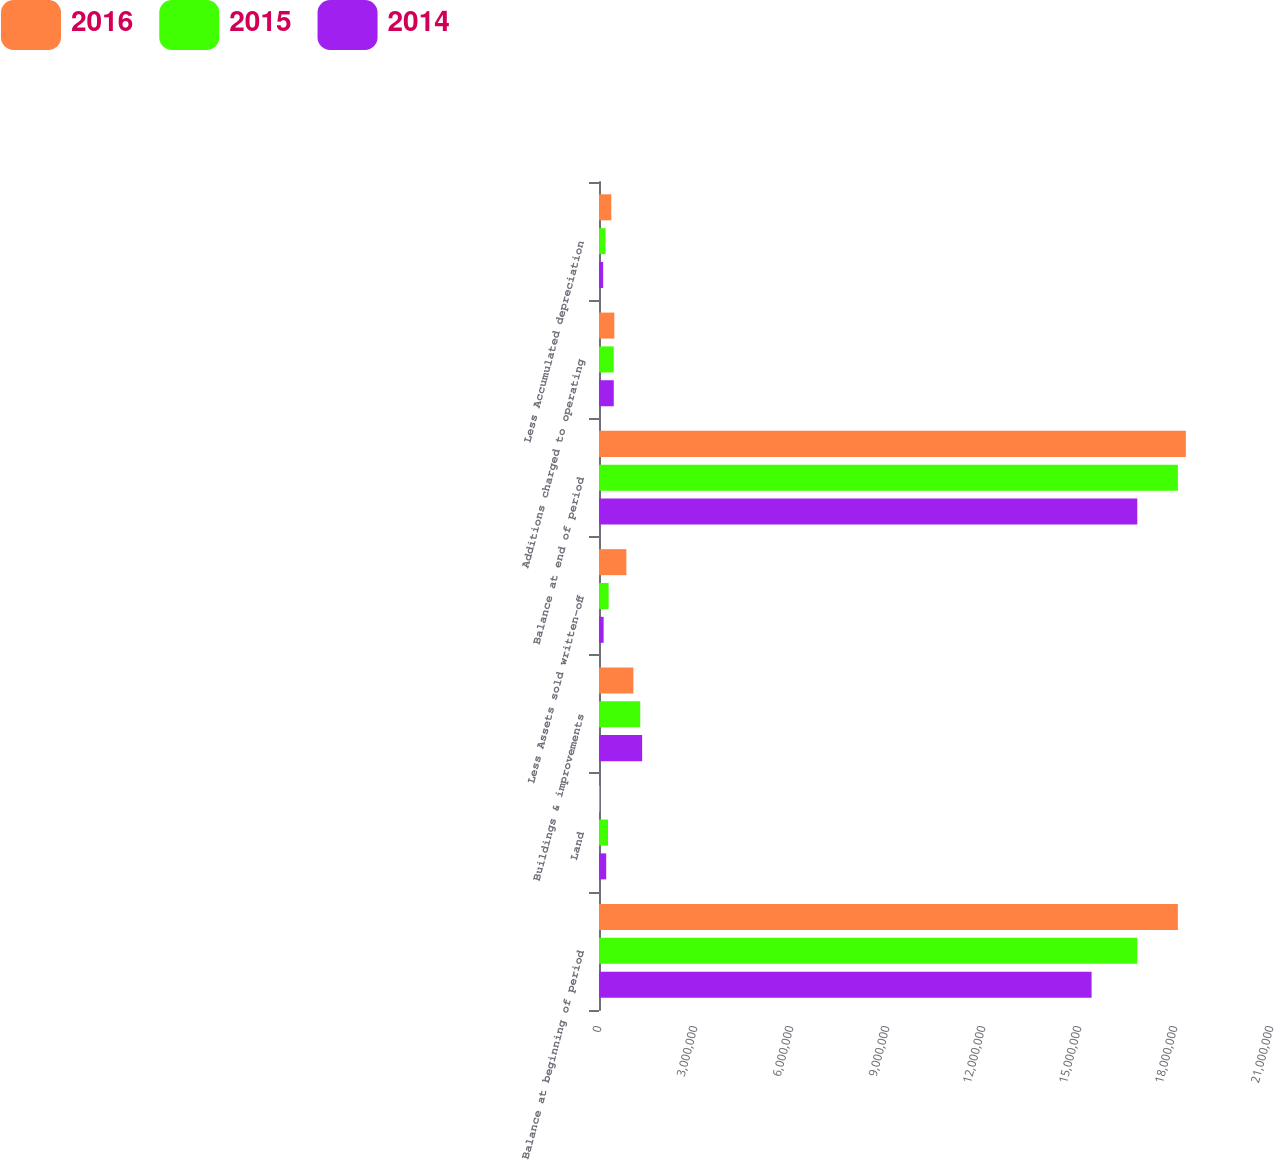<chart> <loc_0><loc_0><loc_500><loc_500><stacked_bar_chart><ecel><fcel>Balance at beginning of period<fcel>Land<fcel>Buildings & improvements<fcel>Less Assets sold written-off<fcel>Balance at end of period<fcel>Additions charged to operating<fcel>Less Accumulated depreciation<nl><fcel>2016<fcel>1.80901e+07<fcel>30805<fcel>1.07426e+06<fcel>855243<fcel>1.834e+07<fcel>478788<fcel>383481<nl><fcel>2015<fcel>1.68224e+07<fcel>281048<fcel>1.28814e+06<fcel>301405<fcel>1.80901e+07<fcel>459612<fcel>202978<nl><fcel>2014<fcel>1.5393e+07<fcel>225536<fcel>1.34815e+06<fcel>144299<fcel>1.68224e+07<fcel>461689<fcel>129918<nl></chart> 